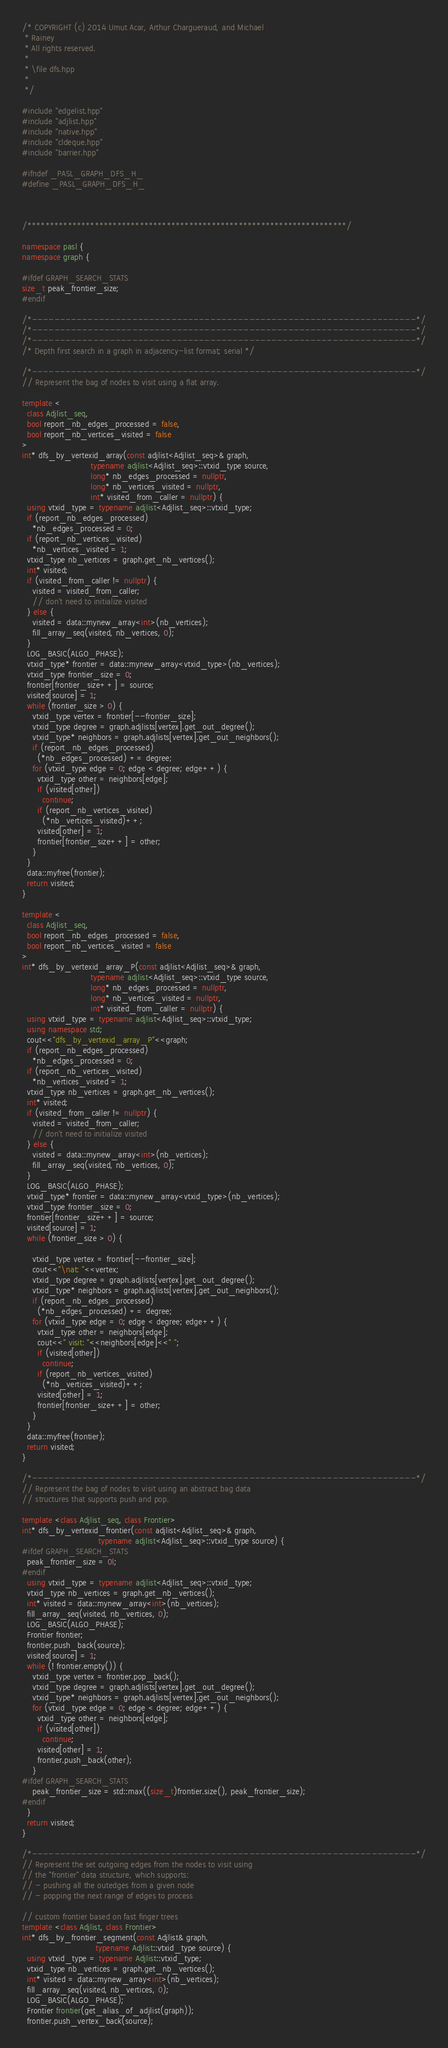Convert code to text. <code><loc_0><loc_0><loc_500><loc_500><_C++_>/* COPYRIGHT (c) 2014 Umut Acar, Arthur Chargueraud, and Michael
 * Rainey
 * All rights reserved.
 *
 * \file dfs.hpp
 *
 */

#include "edgelist.hpp"
#include "adjlist.hpp"
#include "native.hpp"
#include "cldeque.hpp"
#include "barrier.hpp"

#ifndef _PASL_GRAPH_DFS_H_
#define _PASL_GRAPH_DFS_H_



/***********************************************************************/

namespace pasl {
namespace graph {

#ifdef GRAPH_SEARCH_STATS
size_t peak_frontier_size;
#endif

/*---------------------------------------------------------------------*/
/*---------------------------------------------------------------------*/
/*---------------------------------------------------------------------*/
/* Depth first search in a graph in adjacency-list format; serial */

/*---------------------------------------------------------------------*/
// Represent the bag of nodes to visit using a flat array.

template <
  class Adjlist_seq,
  bool report_nb_edges_processed = false,
  bool report_nb_vertices_visited = false
>
int* dfs_by_vertexid_array(const adjlist<Adjlist_seq>& graph,
                           typename adjlist<Adjlist_seq>::vtxid_type source,
                           long* nb_edges_processed = nullptr,
                           long* nb_vertices_visited = nullptr,
                           int* visited_from_caller = nullptr) {
  using vtxid_type = typename adjlist<Adjlist_seq>::vtxid_type;
  if (report_nb_edges_processed)
    *nb_edges_processed = 0;
  if (report_nb_vertices_visited)
    *nb_vertices_visited = 1;
  vtxid_type nb_vertices = graph.get_nb_vertices();
  int* visited;
  if (visited_from_caller != nullptr) {
    visited = visited_from_caller;
    // don't need to initialize visited
  } else {
    visited = data::mynew_array<int>(nb_vertices);
    fill_array_seq(visited, nb_vertices, 0);
  }
  LOG_BASIC(ALGO_PHASE);
  vtxid_type* frontier = data::mynew_array<vtxid_type>(nb_vertices);
  vtxid_type frontier_size = 0;
  frontier[frontier_size++] = source;
  visited[source] = 1;
  while (frontier_size > 0) {
    vtxid_type vertex = frontier[--frontier_size];
    vtxid_type degree = graph.adjlists[vertex].get_out_degree();
    vtxid_type* neighbors = graph.adjlists[vertex].get_out_neighbors();
    if (report_nb_edges_processed)
      (*nb_edges_processed) += degree;
    for (vtxid_type edge = 0; edge < degree; edge++) {
      vtxid_type other = neighbors[edge];
      if (visited[other])
        continue;
      if (report_nb_vertices_visited)
        (*nb_vertices_visited)++;
      visited[other] = 1;
      frontier[frontier_size++] = other;
    }
  }
  data::myfree(frontier);
  return visited;
}

template <
  class Adjlist_seq,
  bool report_nb_edges_processed = false,
  bool report_nb_vertices_visited = false
>
int* dfs_by_vertexid_array_P(const adjlist<Adjlist_seq>& graph,
                           typename adjlist<Adjlist_seq>::vtxid_type source,
                           long* nb_edges_processed = nullptr,
                           long* nb_vertices_visited = nullptr,
                           int* visited_from_caller = nullptr) {
  using vtxid_type = typename adjlist<Adjlist_seq>::vtxid_type;
  using namespace std;
  cout<<"dfs_by_vertexid_array_P"<<graph;
  if (report_nb_edges_processed)
    *nb_edges_processed = 0;
  if (report_nb_vertices_visited)
    *nb_vertices_visited = 1;
  vtxid_type nb_vertices = graph.get_nb_vertices();
  int* visited;
  if (visited_from_caller != nullptr) {
    visited = visited_from_caller;
    // don't need to initialize visited
  } else {
    visited = data::mynew_array<int>(nb_vertices);
    fill_array_seq(visited, nb_vertices, 0);
  }
  LOG_BASIC(ALGO_PHASE);
  vtxid_type* frontier = data::mynew_array<vtxid_type>(nb_vertices);
  vtxid_type frontier_size = 0;
  frontier[frontier_size++] = source;
  visited[source] = 1;
  while (frontier_size > 0) {
    
    vtxid_type vertex = frontier[--frontier_size];
    cout<<"\nat: "<<vertex;
    vtxid_type degree = graph.adjlists[vertex].get_out_degree();
    vtxid_type* neighbors = graph.adjlists[vertex].get_out_neighbors();
    if (report_nb_edges_processed)
      (*nb_edges_processed) += degree;
    for (vtxid_type edge = 0; edge < degree; edge++) {
      vtxid_type other = neighbors[edge];
      cout<<" visit: "<<neighbors[edge]<<" ";
      if (visited[other])
        continue;
      if (report_nb_vertices_visited)
        (*nb_vertices_visited)++;
      visited[other] = 1;
      frontier[frontier_size++] = other;
    }
  }
  data::myfree(frontier);
  return visited;
}

/*---------------------------------------------------------------------*/
// Represent the bag of nodes to visit using an abstract bag data
// structures that supports push and pop.

template <class Adjlist_seq, class Frontier>
int* dfs_by_vertexid_frontier(const adjlist<Adjlist_seq>& graph,
                              typename adjlist<Adjlist_seq>::vtxid_type source) {
#ifdef GRAPH_SEARCH_STATS
  peak_frontier_size = 0l;
#endif
  using vtxid_type = typename adjlist<Adjlist_seq>::vtxid_type;
  vtxid_type nb_vertices = graph.get_nb_vertices();
  int* visited = data::mynew_array<int>(nb_vertices);
  fill_array_seq(visited, nb_vertices, 0);
  LOG_BASIC(ALGO_PHASE);
  Frontier frontier;
  frontier.push_back(source);
  visited[source] = 1;
  while (! frontier.empty()) {
    vtxid_type vertex = frontier.pop_back();
    vtxid_type degree = graph.adjlists[vertex].get_out_degree();
    vtxid_type* neighbors = graph.adjlists[vertex].get_out_neighbors();
    for (vtxid_type edge = 0; edge < degree; edge++) {
      vtxid_type other = neighbors[edge];
      if (visited[other])
        continue;
      visited[other] = 1;
      frontier.push_back(other);
    }
#ifdef GRAPH_SEARCH_STATS
    peak_frontier_size = std::max((size_t)frontier.size(), peak_frontier_size);
#endif
  }
  return visited;
}

/*---------------------------------------------------------------------*/
// Represent the set outgoing edges from the nodes to visit using 
// the "frontier" data structure, which supports:
// - pushing all the outedges from a given node
// - popping the next range of edges to process

// custom frontier based on fast finger trees
template <class Adjlist, class Frontier>
int* dfs_by_frontier_segment(const Adjlist& graph,
                             typename Adjlist::vtxid_type source) {
  using vtxid_type = typename Adjlist::vtxid_type;
  vtxid_type nb_vertices = graph.get_nb_vertices();
  int* visited = data::mynew_array<int>(nb_vertices);
  fill_array_seq(visited, nb_vertices, 0);
  LOG_BASIC(ALGO_PHASE);
  Frontier frontier(get_alias_of_adjlist(graph));
  frontier.push_vertex_back(source);</code> 